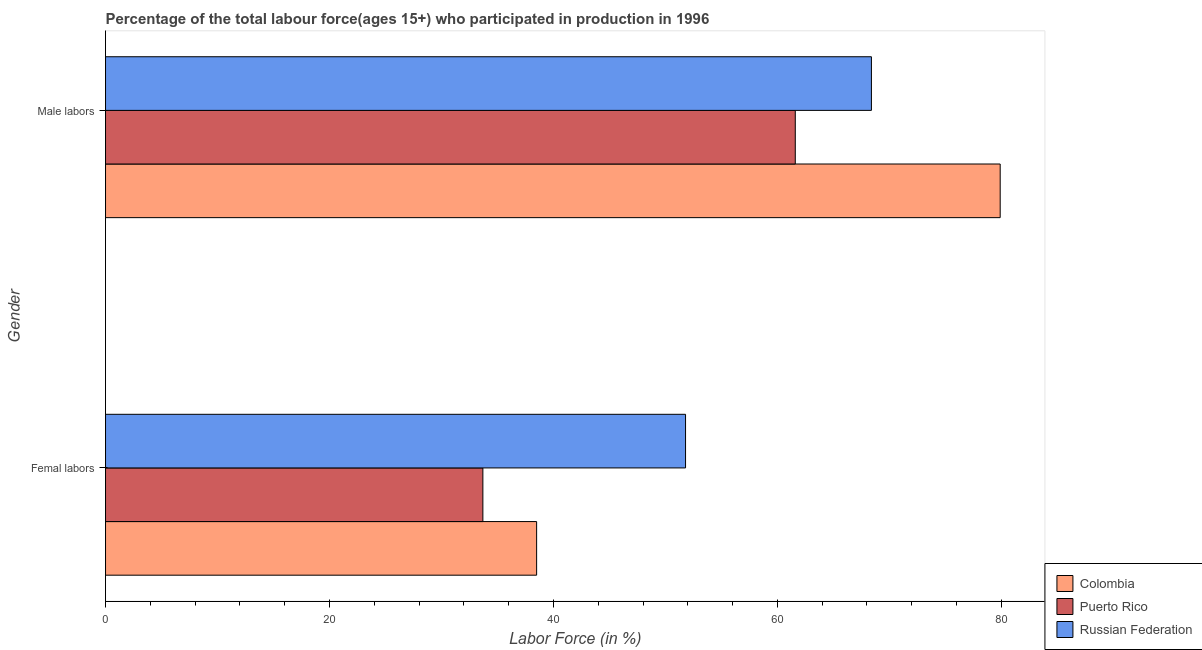Are the number of bars per tick equal to the number of legend labels?
Offer a terse response. Yes. What is the label of the 1st group of bars from the top?
Keep it short and to the point. Male labors. What is the percentage of male labour force in Russian Federation?
Provide a short and direct response. 68.4. Across all countries, what is the maximum percentage of female labor force?
Your answer should be compact. 51.8. Across all countries, what is the minimum percentage of male labour force?
Make the answer very short. 61.6. In which country was the percentage of male labour force minimum?
Ensure brevity in your answer.  Puerto Rico. What is the total percentage of female labor force in the graph?
Your response must be concise. 124. What is the difference between the percentage of female labor force in Puerto Rico and that in Russian Federation?
Make the answer very short. -18.1. What is the difference between the percentage of male labour force in Russian Federation and the percentage of female labor force in Puerto Rico?
Your answer should be compact. 34.7. What is the average percentage of female labor force per country?
Offer a very short reply. 41.33. What is the difference between the percentage of male labour force and percentage of female labor force in Colombia?
Provide a succinct answer. 41.4. What is the ratio of the percentage of female labor force in Puerto Rico to that in Russian Federation?
Offer a terse response. 0.65. Is the percentage of male labour force in Colombia less than that in Russian Federation?
Keep it short and to the point. No. In how many countries, is the percentage of female labor force greater than the average percentage of female labor force taken over all countries?
Keep it short and to the point. 1. What does the 3rd bar from the bottom in Femal labors represents?
Provide a short and direct response. Russian Federation. How many bars are there?
Offer a terse response. 6. Are all the bars in the graph horizontal?
Give a very brief answer. Yes. Are the values on the major ticks of X-axis written in scientific E-notation?
Ensure brevity in your answer.  No. Does the graph contain any zero values?
Offer a very short reply. No. Does the graph contain grids?
Your answer should be compact. No. How many legend labels are there?
Provide a short and direct response. 3. How are the legend labels stacked?
Provide a short and direct response. Vertical. What is the title of the graph?
Your answer should be very brief. Percentage of the total labour force(ages 15+) who participated in production in 1996. What is the label or title of the Y-axis?
Your response must be concise. Gender. What is the Labor Force (in %) in Colombia in Femal labors?
Provide a succinct answer. 38.5. What is the Labor Force (in %) of Puerto Rico in Femal labors?
Provide a succinct answer. 33.7. What is the Labor Force (in %) in Russian Federation in Femal labors?
Give a very brief answer. 51.8. What is the Labor Force (in %) of Colombia in Male labors?
Give a very brief answer. 79.9. What is the Labor Force (in %) in Puerto Rico in Male labors?
Keep it short and to the point. 61.6. What is the Labor Force (in %) of Russian Federation in Male labors?
Provide a short and direct response. 68.4. Across all Gender, what is the maximum Labor Force (in %) of Colombia?
Provide a short and direct response. 79.9. Across all Gender, what is the maximum Labor Force (in %) of Puerto Rico?
Provide a succinct answer. 61.6. Across all Gender, what is the maximum Labor Force (in %) in Russian Federation?
Offer a terse response. 68.4. Across all Gender, what is the minimum Labor Force (in %) in Colombia?
Make the answer very short. 38.5. Across all Gender, what is the minimum Labor Force (in %) in Puerto Rico?
Your answer should be very brief. 33.7. Across all Gender, what is the minimum Labor Force (in %) in Russian Federation?
Offer a terse response. 51.8. What is the total Labor Force (in %) in Colombia in the graph?
Offer a very short reply. 118.4. What is the total Labor Force (in %) of Puerto Rico in the graph?
Provide a succinct answer. 95.3. What is the total Labor Force (in %) in Russian Federation in the graph?
Ensure brevity in your answer.  120.2. What is the difference between the Labor Force (in %) of Colombia in Femal labors and that in Male labors?
Offer a terse response. -41.4. What is the difference between the Labor Force (in %) of Puerto Rico in Femal labors and that in Male labors?
Ensure brevity in your answer.  -27.9. What is the difference between the Labor Force (in %) of Russian Federation in Femal labors and that in Male labors?
Offer a terse response. -16.6. What is the difference between the Labor Force (in %) in Colombia in Femal labors and the Labor Force (in %) in Puerto Rico in Male labors?
Offer a terse response. -23.1. What is the difference between the Labor Force (in %) in Colombia in Femal labors and the Labor Force (in %) in Russian Federation in Male labors?
Your answer should be very brief. -29.9. What is the difference between the Labor Force (in %) in Puerto Rico in Femal labors and the Labor Force (in %) in Russian Federation in Male labors?
Ensure brevity in your answer.  -34.7. What is the average Labor Force (in %) of Colombia per Gender?
Offer a very short reply. 59.2. What is the average Labor Force (in %) in Puerto Rico per Gender?
Provide a short and direct response. 47.65. What is the average Labor Force (in %) in Russian Federation per Gender?
Your answer should be compact. 60.1. What is the difference between the Labor Force (in %) of Colombia and Labor Force (in %) of Russian Federation in Femal labors?
Your answer should be very brief. -13.3. What is the difference between the Labor Force (in %) in Puerto Rico and Labor Force (in %) in Russian Federation in Femal labors?
Provide a short and direct response. -18.1. What is the difference between the Labor Force (in %) in Colombia and Labor Force (in %) in Puerto Rico in Male labors?
Your response must be concise. 18.3. What is the ratio of the Labor Force (in %) of Colombia in Femal labors to that in Male labors?
Ensure brevity in your answer.  0.48. What is the ratio of the Labor Force (in %) in Puerto Rico in Femal labors to that in Male labors?
Keep it short and to the point. 0.55. What is the ratio of the Labor Force (in %) in Russian Federation in Femal labors to that in Male labors?
Keep it short and to the point. 0.76. What is the difference between the highest and the second highest Labor Force (in %) of Colombia?
Provide a short and direct response. 41.4. What is the difference between the highest and the second highest Labor Force (in %) of Puerto Rico?
Give a very brief answer. 27.9. What is the difference between the highest and the lowest Labor Force (in %) of Colombia?
Your answer should be compact. 41.4. What is the difference between the highest and the lowest Labor Force (in %) of Puerto Rico?
Your answer should be very brief. 27.9. 